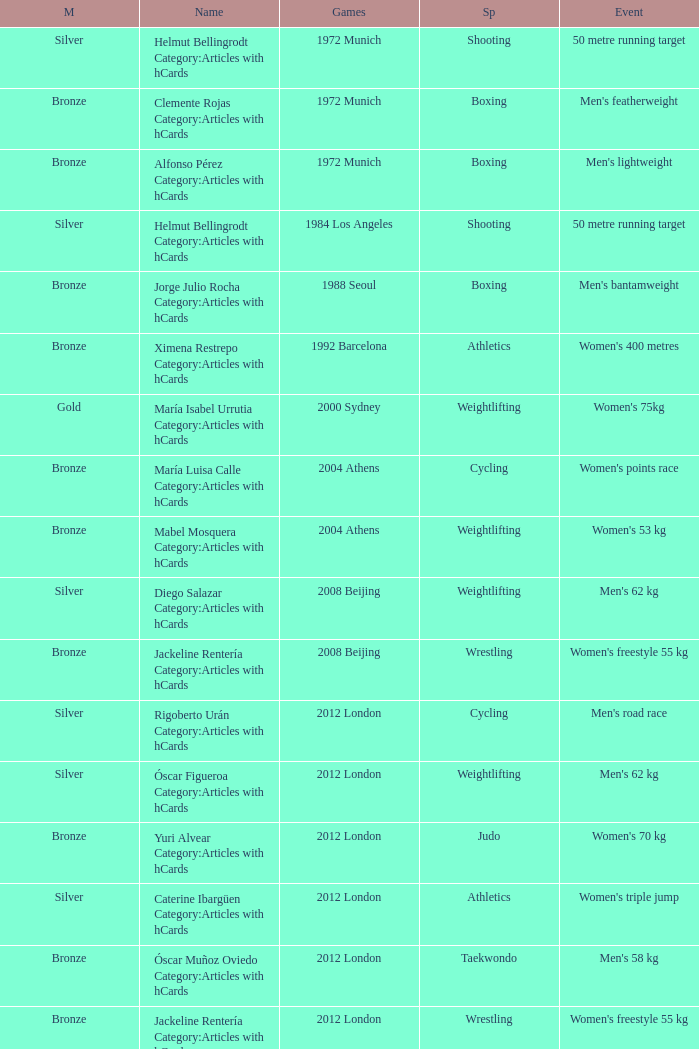Which sport resulted in a gold medal in the 2000 Sydney games? Weightlifting. Can you give me this table as a dict? {'header': ['M', 'Name', 'Games', 'Sp', 'Event'], 'rows': [['Silver', 'Helmut Bellingrodt Category:Articles with hCards', '1972 Munich', 'Shooting', '50 metre running target'], ['Bronze', 'Clemente Rojas Category:Articles with hCards', '1972 Munich', 'Boxing', "Men's featherweight"], ['Bronze', 'Alfonso Pérez Category:Articles with hCards', '1972 Munich', 'Boxing', "Men's lightweight"], ['Silver', 'Helmut Bellingrodt Category:Articles with hCards', '1984 Los Angeles', 'Shooting', '50 metre running target'], ['Bronze', 'Jorge Julio Rocha Category:Articles with hCards', '1988 Seoul', 'Boxing', "Men's bantamweight"], ['Bronze', 'Ximena Restrepo Category:Articles with hCards', '1992 Barcelona', 'Athletics', "Women's 400 metres"], ['Gold', 'María Isabel Urrutia Category:Articles with hCards', '2000 Sydney', 'Weightlifting', "Women's 75kg"], ['Bronze', 'María Luisa Calle Category:Articles with hCards', '2004 Athens', 'Cycling', "Women's points race"], ['Bronze', 'Mabel Mosquera Category:Articles with hCards', '2004 Athens', 'Weightlifting', "Women's 53 kg"], ['Silver', 'Diego Salazar Category:Articles with hCards', '2008 Beijing', 'Weightlifting', "Men's 62 kg"], ['Bronze', 'Jackeline Rentería Category:Articles with hCards', '2008 Beijing', 'Wrestling', "Women's freestyle 55 kg"], ['Silver', 'Rigoberto Urán Category:Articles with hCards', '2012 London', 'Cycling', "Men's road race"], ['Silver', 'Óscar Figueroa Category:Articles with hCards', '2012 London', 'Weightlifting', "Men's 62 kg"], ['Bronze', 'Yuri Alvear Category:Articles with hCards', '2012 London', 'Judo', "Women's 70 kg"], ['Silver', 'Caterine Ibargüen Category:Articles with hCards', '2012 London', 'Athletics', "Women's triple jump"], ['Bronze', 'Óscar Muñoz Oviedo Category:Articles with hCards', '2012 London', 'Taekwondo', "Men's 58 kg"], ['Bronze', 'Jackeline Rentería Category:Articles with hCards', '2012 London', 'Wrestling', "Women's freestyle 55 kg"], ['Gold', 'Mariana Pajón Category:Articles with hCards', '2012 London', 'Cycling', "Women's BMX"], ['Bronze', 'Carlos Oquendo Category:Articles with hCards', '2012 London', 'Cycling', "Men's BMX"]]} 